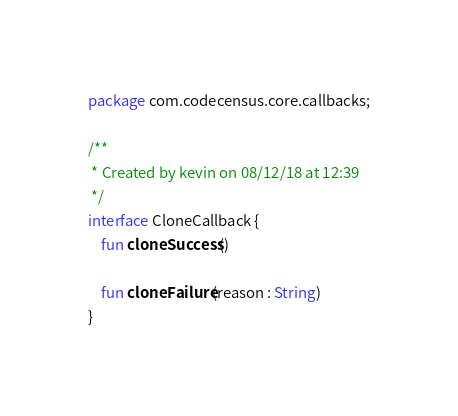<code> <loc_0><loc_0><loc_500><loc_500><_Kotlin_>package com.codecensus.core.callbacks;

/**
 * Created by kevin on 08/12/18 at 12:39
 */
interface CloneCallback {
    fun cloneSuccess()

    fun cloneFailure(reason : String)
}
</code> 